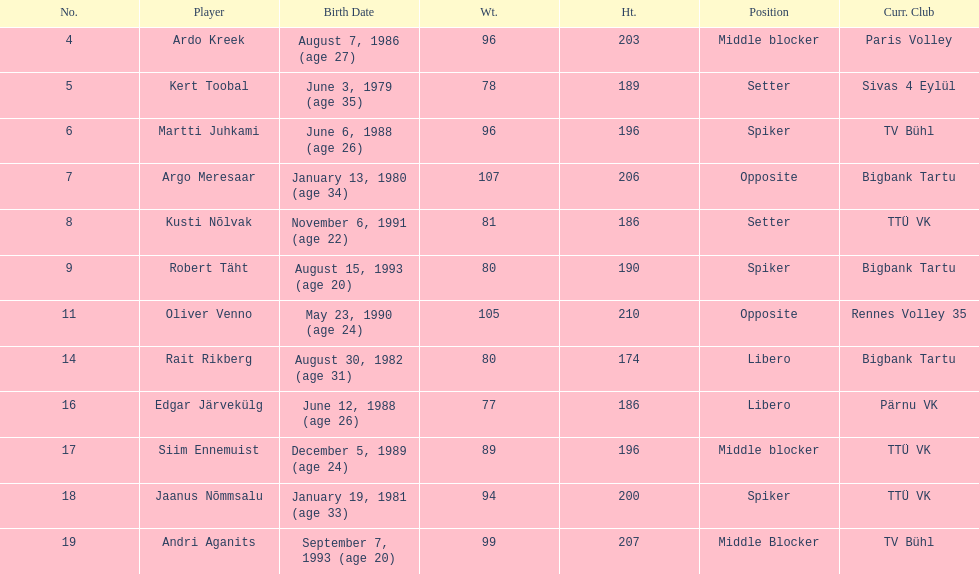Who is the tallest member of estonia's men's national volleyball team? Oliver Venno. 